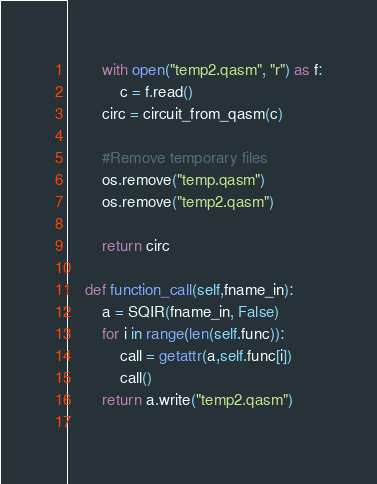Convert code to text. <code><loc_0><loc_0><loc_500><loc_500><_Python_>        with open("temp2.qasm", "r") as f:
            c = f.read()
        circ = circuit_from_qasm(c)
    
        #Remove temporary files
        os.remove("temp.qasm")
        os.remove("temp2.qasm")
        
        return circ
    
    def function_call(self,fname_in):
        a = SQIR(fname_in, False)
        for i in range(len(self.func)):
            call = getattr(a,self.func[i])
            call()
        return a.write("temp2.qasm")   
    
</code> 